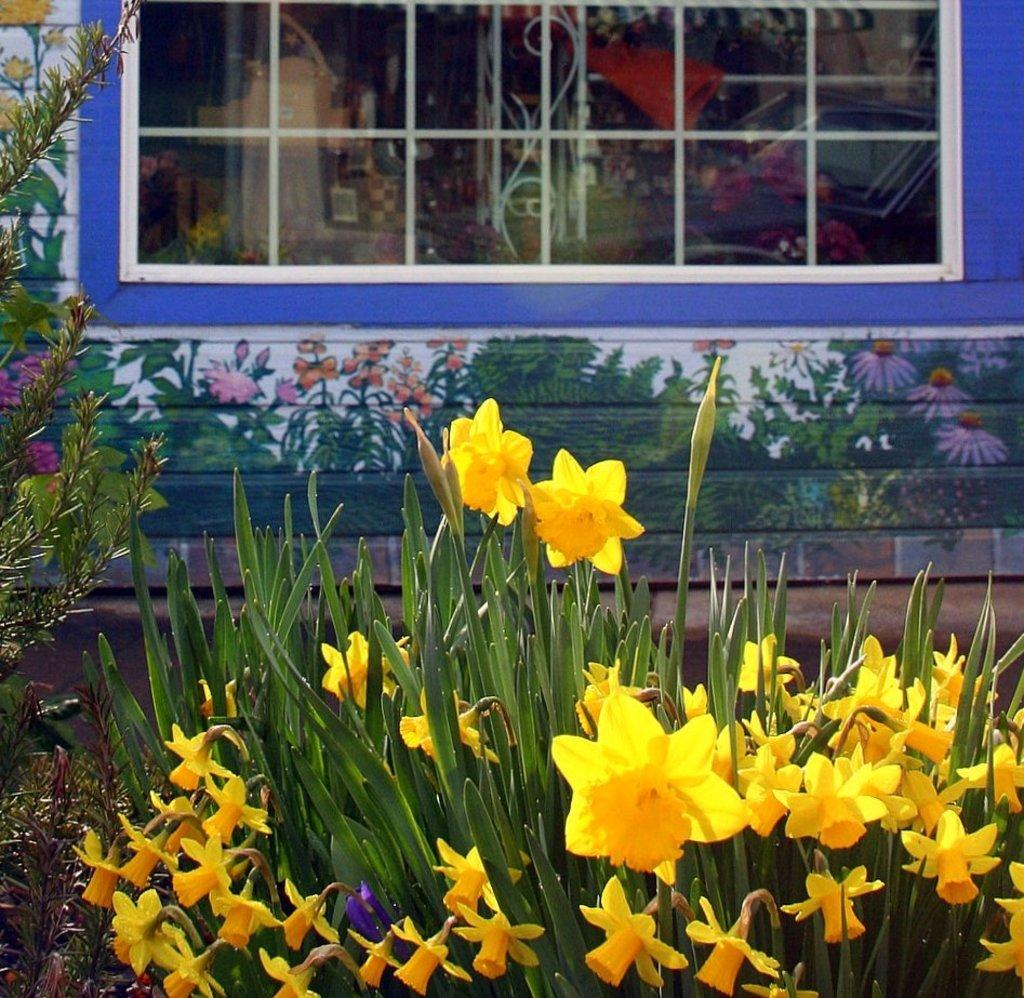What color are the flowers on the plants in the image? The flowers on the plants in the image are yellow. What can be seen on the wall of a building in the image? There is a window visible on the wall of a building in the image. What type of artwork is present on the wall in the image? Paintings of plants and flowers are present on the wall in the image. Can you hear the sound of a guitar being played in the image? There is no guitar or sound present in the image. Are there any visible veins on the plants in the image? The image does not show any visible veins on the plants; it only shows the flowers. 